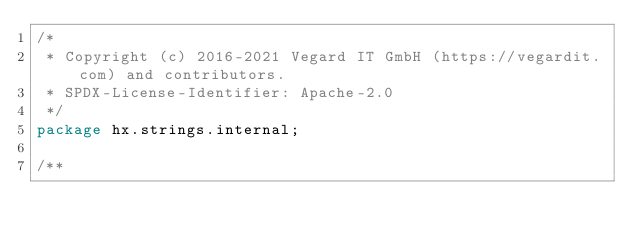Convert code to text. <code><loc_0><loc_0><loc_500><loc_500><_Haxe_>/*
 * Copyright (c) 2016-2021 Vegard IT GmbH (https://vegardit.com) and contributors.
 * SPDX-License-Identifier: Apache-2.0
 */
package hx.strings.internal;

/**</code> 